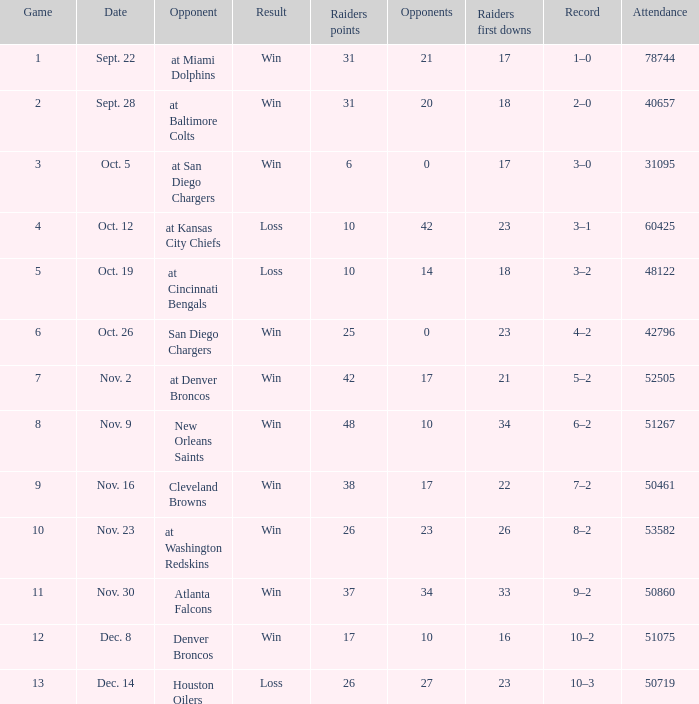How many different counts of the Raiders first downs are there for the game number 9? 1.0. 